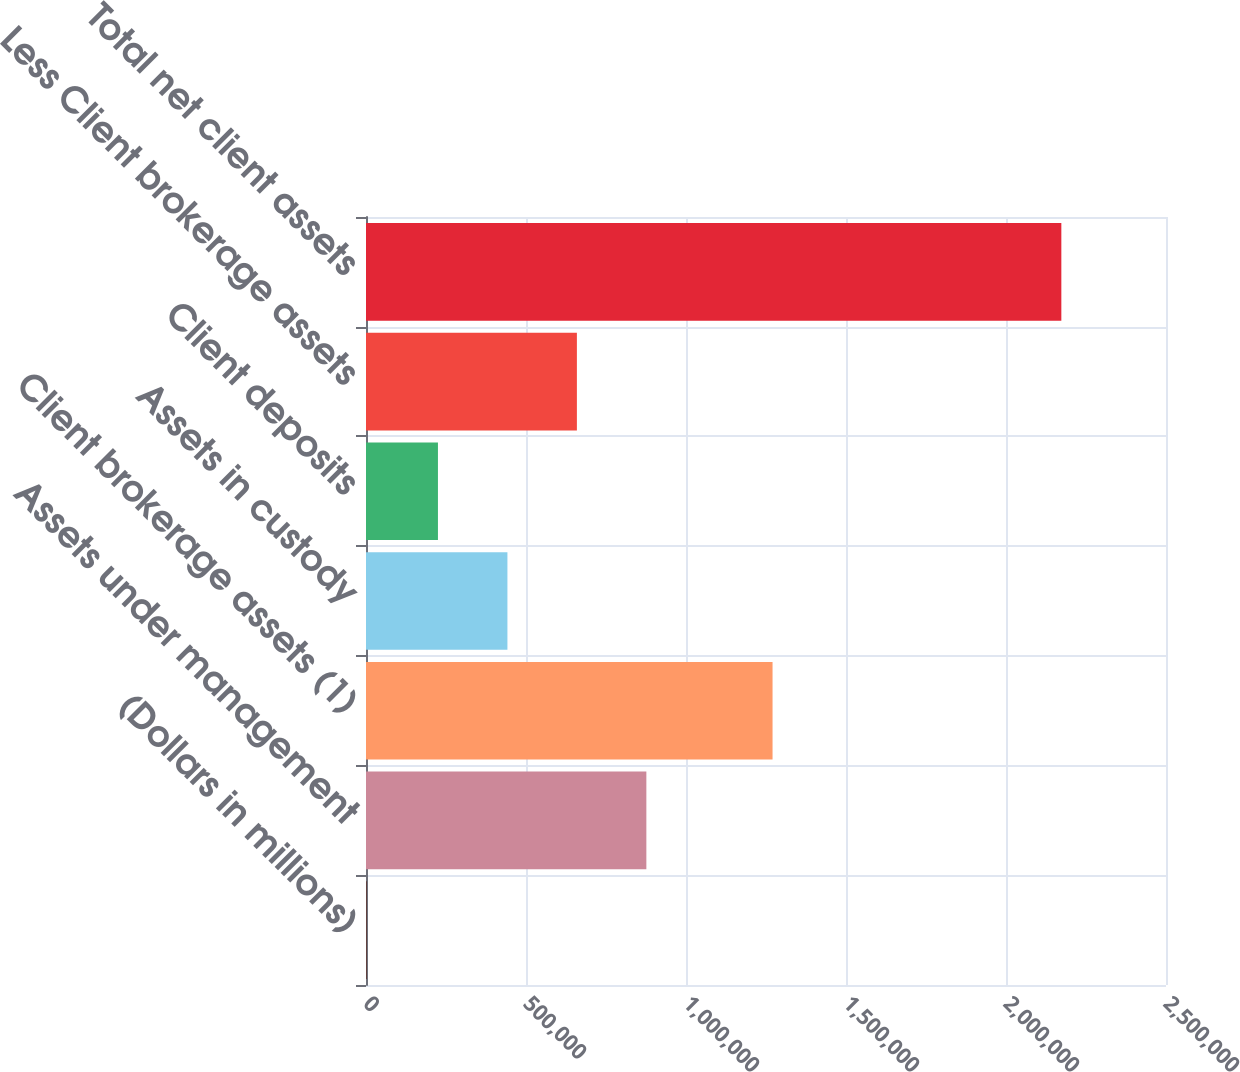<chart> <loc_0><loc_0><loc_500><loc_500><bar_chart><fcel>(Dollars in millions)<fcel>Assets under management<fcel>Client brokerage assets (1)<fcel>Assets in custody<fcel>Client deposits<fcel>Less Client brokerage assets<fcel>Total net client assets<nl><fcel>2009<fcel>876120<fcel>1.27046e+06<fcel>441933<fcel>224840<fcel>659027<fcel>2.17294e+06<nl></chart> 